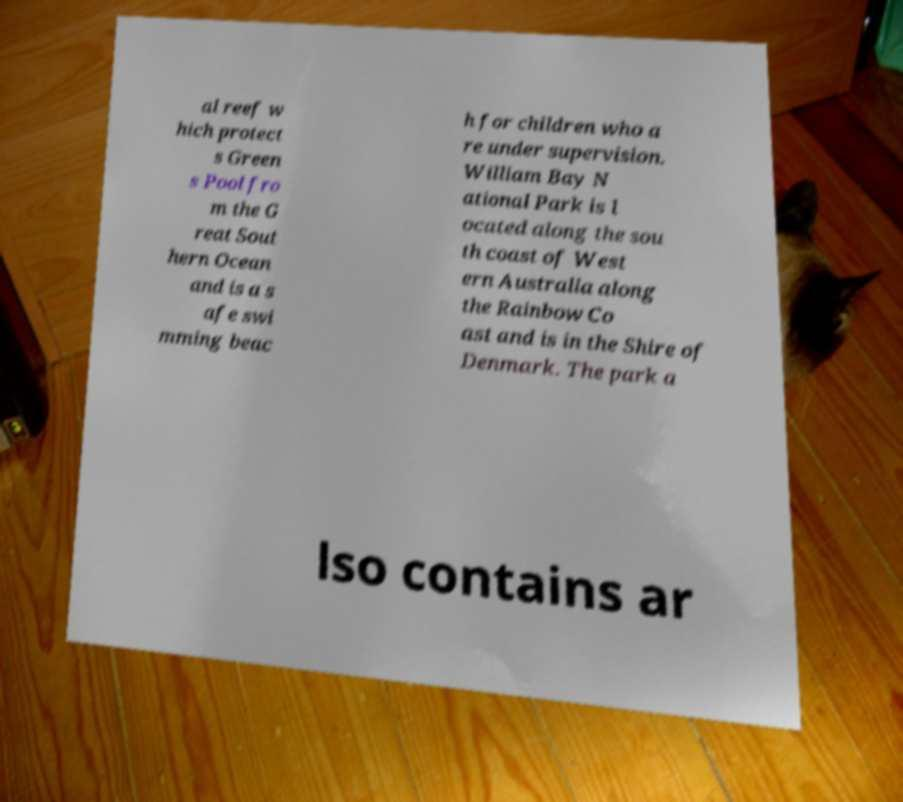There's text embedded in this image that I need extracted. Can you transcribe it verbatim? al reef w hich protect s Green s Pool fro m the G reat Sout hern Ocean and is a s afe swi mming beac h for children who a re under supervision. William Bay N ational Park is l ocated along the sou th coast of West ern Australia along the Rainbow Co ast and is in the Shire of Denmark. The park a lso contains ar 